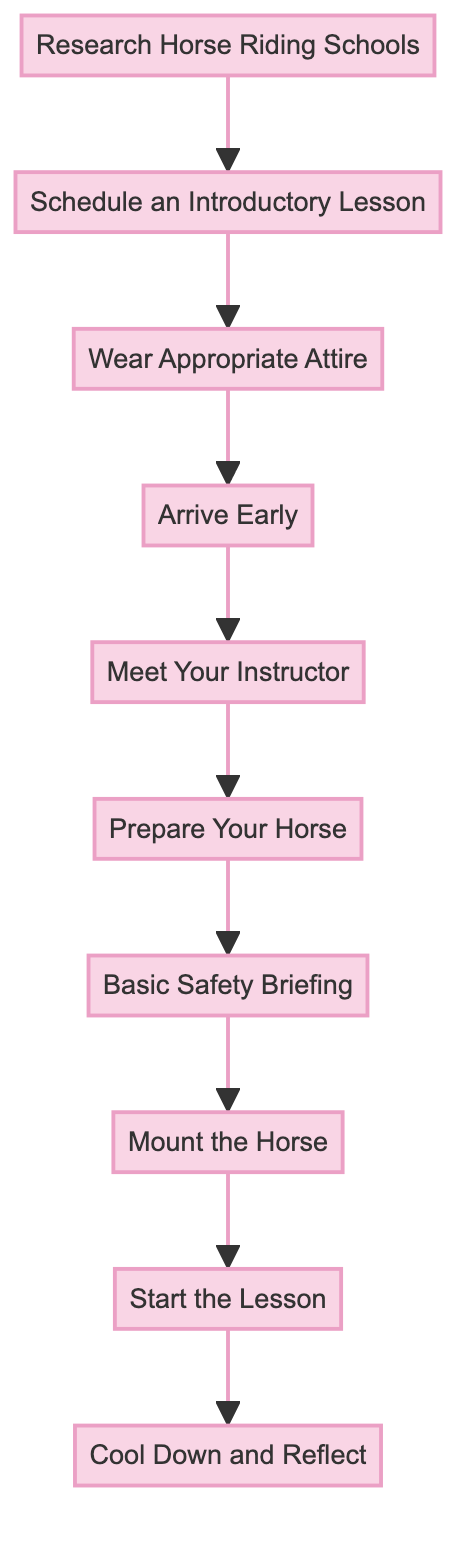What is the first step in preparing for a horse riding lesson? The first step is "Research Horse Riding Schools," as indicated at the top of the flowchart.
Answer: Research Horse Riding Schools How many total steps are there in the process? Counting all the steps listed in the flowchart from start to finish, there are ten different steps depicted.
Answer: 10 What is the last step in the flowchart? The last step is "Cool Down and Reflect," which is shown at the bottom of the flowchart, indicating the conclusion of the process.
Answer: Cool Down and Reflect Which step comes directly after "Prepare Your Horse"? The step that follows "Prepare Your Horse" is "Basic Safety Briefing," as indicated by the flow direction from one step to the next.
Answer: Basic Safety Briefing What do you need to do before you "Mount the Horse"? You must complete the "Basic Safety Briefing" step before proceeding to "Mount the Horse," linking these two steps sequentially.
Answer: Basic Safety Briefing Name the step that involves wearing specific clothing for riding. The step that pertains to attire is "Wear Appropriate Attire," highlighting the importance of dressing suitably for riding.
Answer: Wear Appropriate Attire What should you do right after meeting your instructor? After meeting your instructor, the next step is to "Prepare Your Horse," which is the subsequent action in the flow sequence.
Answer: Prepare Your Horse How can you ensure comfort before starting your lesson? Arriving early is crucial; as indicated in the flowchart, arriving early allows you to get acquainted with the environment and relax before the lesson starts.
Answer: Arrive Early What action follows "Schedule an Introductory Lesson"? After "Schedule an Introductory Lesson," the subsequent step is to "Wear Appropriate Attire," making sure you are dressed correctly for riding.
Answer: Wear Appropriate Attire 